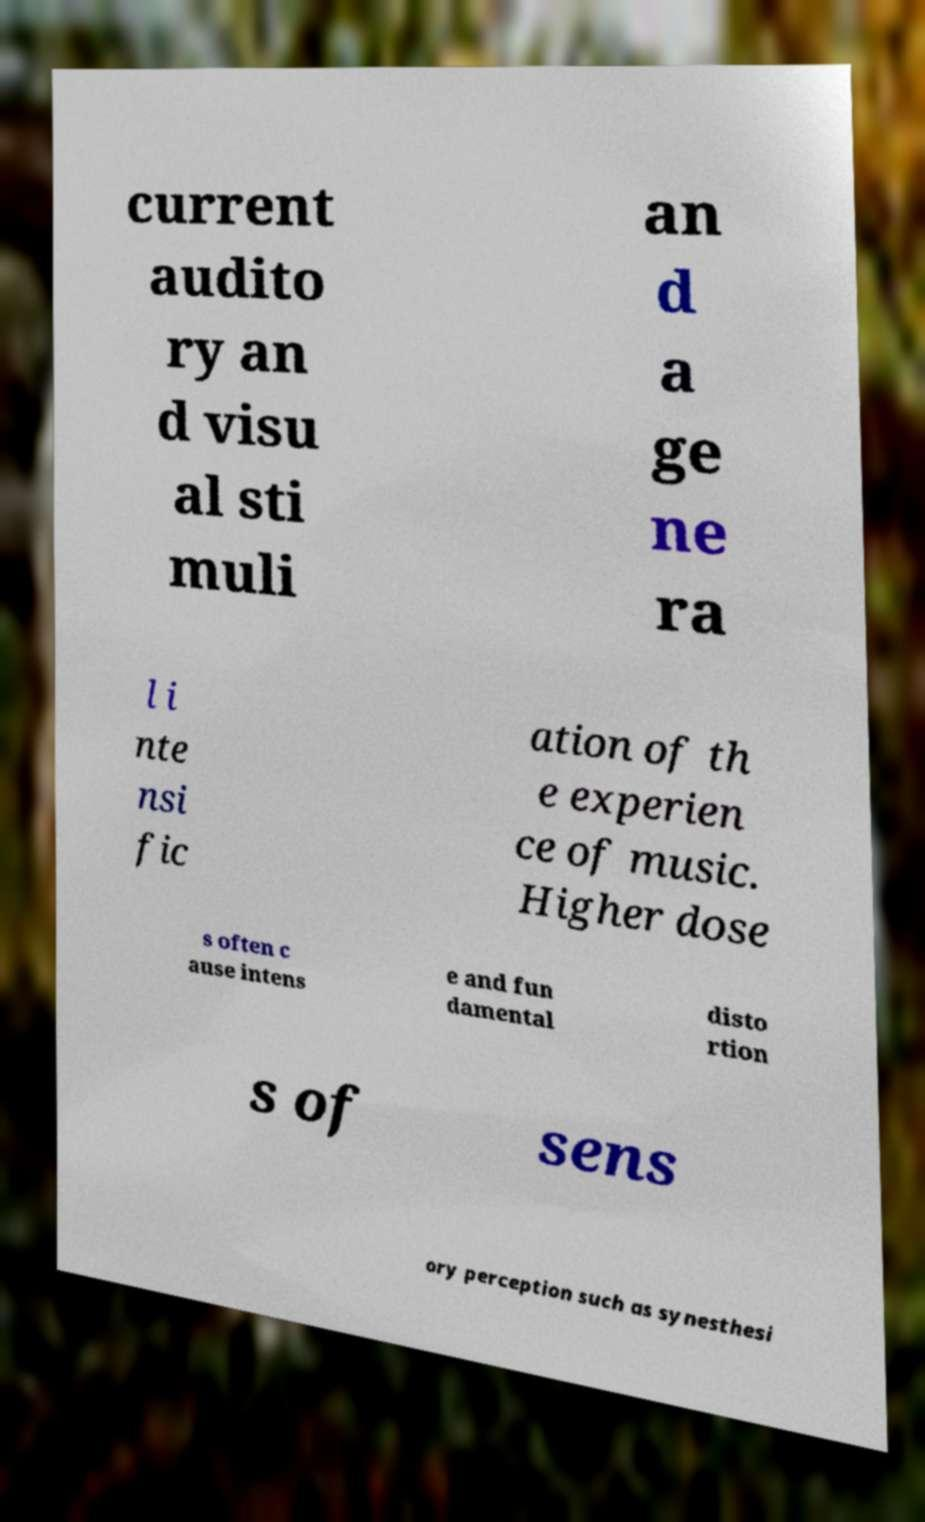Can you accurately transcribe the text from the provided image for me? current audito ry an d visu al sti muli an d a ge ne ra l i nte nsi fic ation of th e experien ce of music. Higher dose s often c ause intens e and fun damental disto rtion s of sens ory perception such as synesthesi 